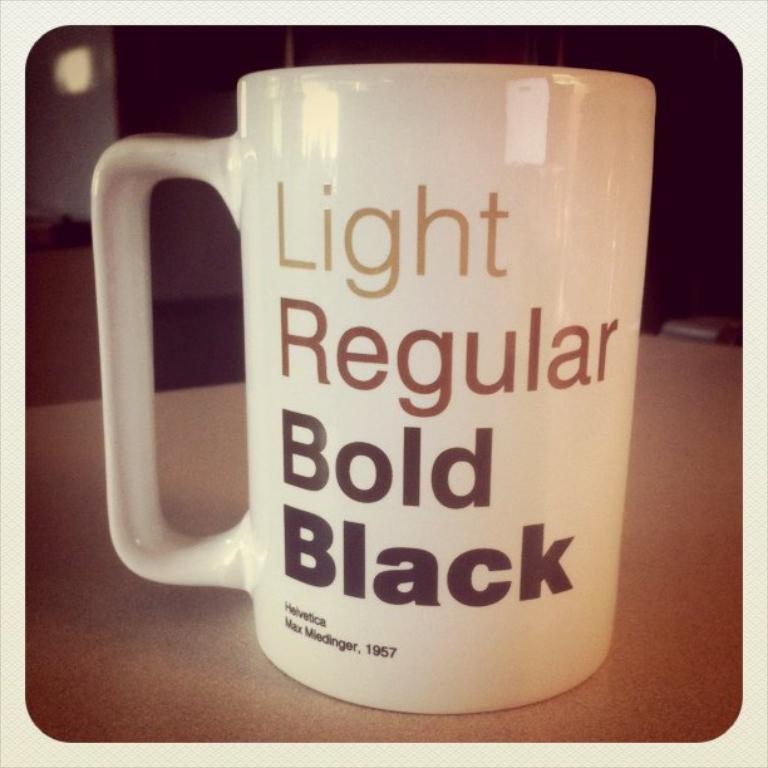What is written on the coffee cup?
Keep it short and to the point. Light regular bold black. What year is written on the bottom of the coffee cup?
Your answer should be very brief. 1957. 